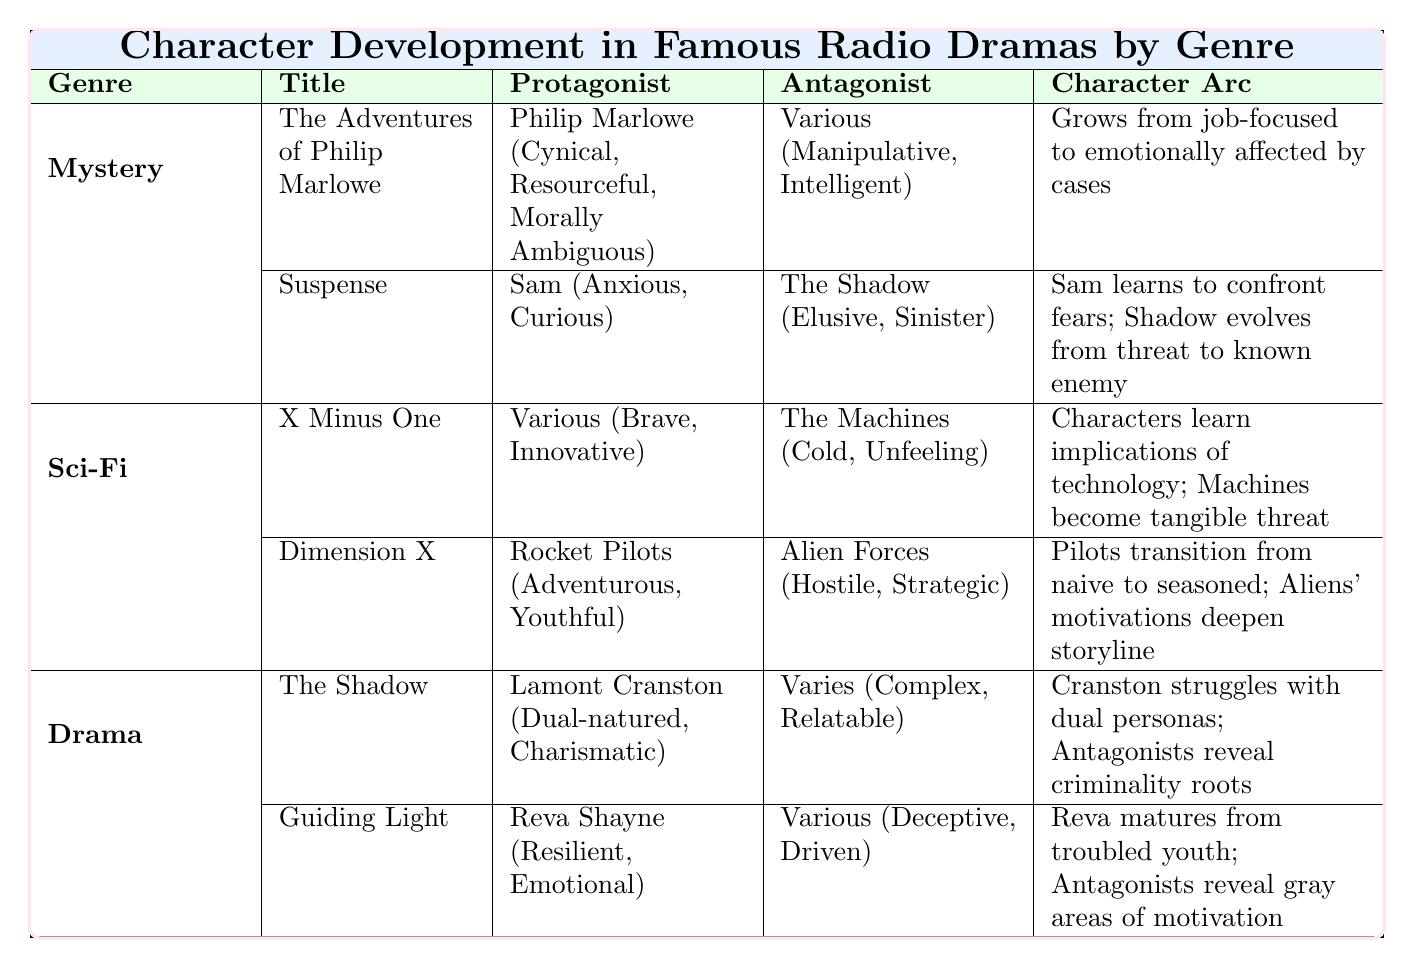What are the traits of the protagonist in "The Adventures of Philip Marlowe"? The table shows that Philip Marlowe, the protagonist, has the traits "Cynical," "Resourceful," and "Morally Ambiguous."
Answer: Cynical, Resourceful, Morally Ambiguous What character arc does Reva Shayne undergo in "Guiding Light"? According to the table, Reva Shayne transitions from a troubled youth to a mature woman who finds love and stability.
Answer: From troubled youth to mature woman Is the protagonist of "Suspense" named Sam? The table states that the protagonist in "Suspense" is indeed named Sam.
Answer: Yes How many distinct genres of radio dramas are represented in the table? The table lists three genres: Mystery, Sci-Fi, and Drama. Thus, there are three genres.
Answer: Three What is the character arc of the protagonist in "Dimension X"? The table indicates that the Rocket Pilots in "Dimension X" transition from naive explorers to seasoned space travelers facing reality.
Answer: From naive explorers to seasoned space travelers Do the antagonists in the dramas have complex portrayals? The table reveals that both the antagonists in "The Shadow" and "Guiding Light" have complex character arcs, indicating that they are indeed portrayed complexly.
Answer: Yes What traits do the antagonists in the Mystery genre share? The table lists that the antagonists in the Mystery genre are "Manipulative" and "Intelligent," which shows a shared focus on being deceitful and clever.
Answer: Manipulative, Intelligent How do the traits of antagonists in the Sci-Fi genre differ from those in the Mystery genre? The antagonists in the Sci-Fi genre are described as "Cold" and "Unfeeling," whereas the Mystery genre's antagonists are "Manipulative" and "Intelligent." This indicates that Sci-Fi antagonists focus more on emotional detachment while Mystery antagonists focus on manipulation and cleverness.
Answer: They differ in emotional detachment vs manipulation What transformation does Sam undergo throughout the "Suspense" series? The protagonist Sam learns to confront his fears as the mysteries unfold, depicting his personal growth in facing challenges.
Answer: Learns to confront fears 